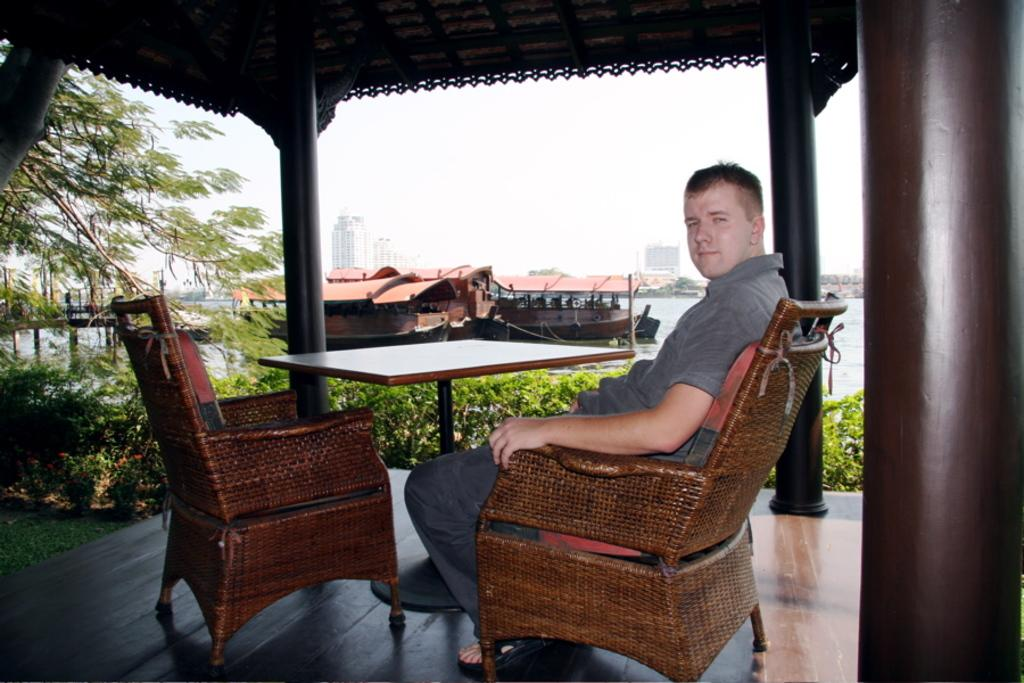What is the person in the image doing? The person is sitting on a chair in the image. What furniture is visible beside the person? There is a table and chair beside the person. What type of vegetation can be seen in the image? There are plants and trees in the image. What can be seen in the background of the image? There are boats on the water in the background of the image. What smell is coming from the bedroom in the image? There is no bedroom present in the image, so it is not possible to determine any smells. 